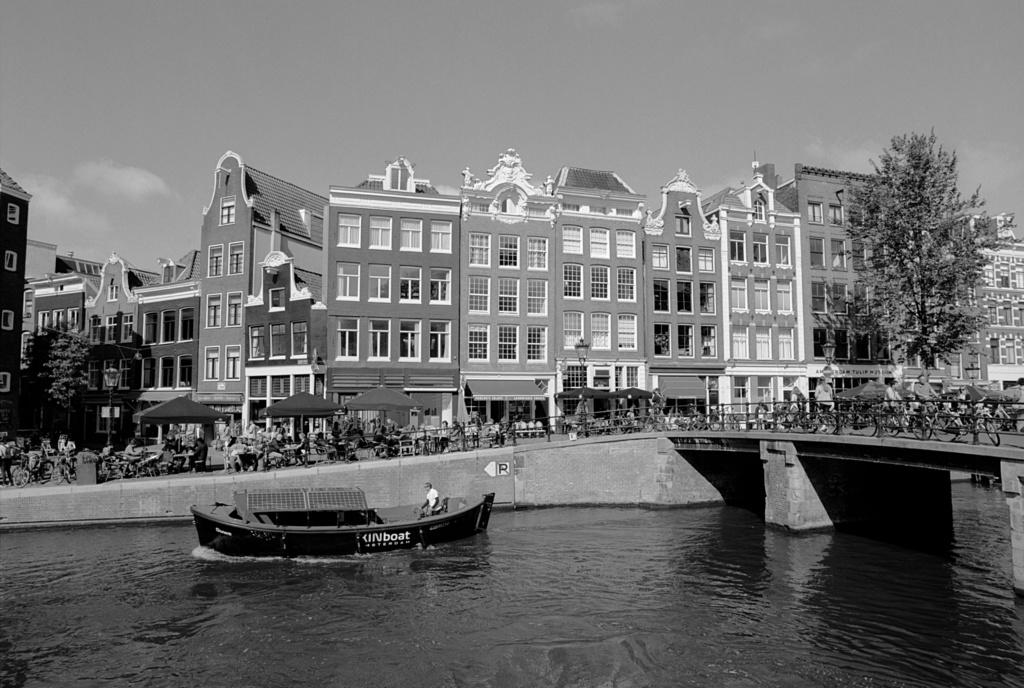What type of structures can be seen in the image? There are buildings in the image. What other natural elements are present in the image? There are trees in the image. What is floating on the water in the image? There is a boat in the water in the image. What part of the natural environment is visible in the image? The sky is visible in the image. What type of hole can be seen in the boat in the image? There is no hole present in the boat in the image. What is the effect of the wax on the trees in the image? There is no wax present in the image, so its effect cannot be determined. 